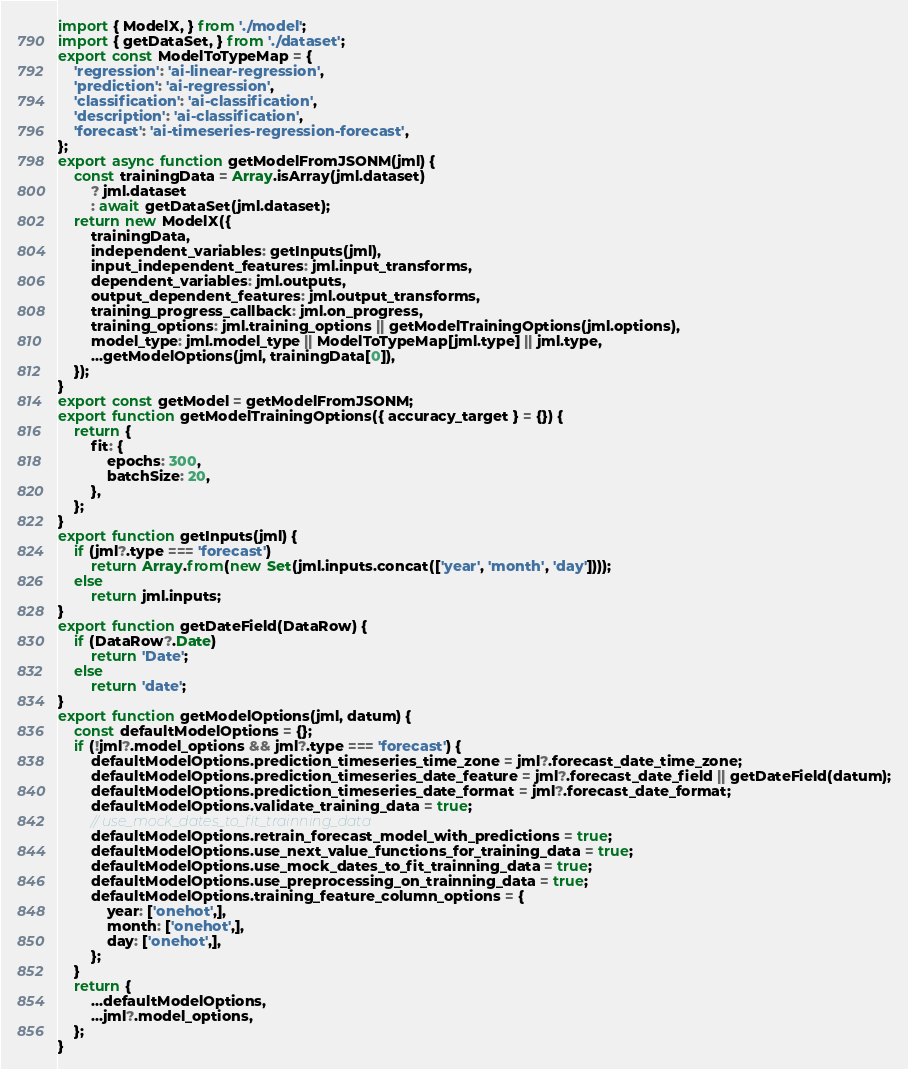Convert code to text. <code><loc_0><loc_0><loc_500><loc_500><_JavaScript_>import { ModelX, } from './model';
import { getDataSet, } from './dataset';
export const ModelToTypeMap = {
    'regression': 'ai-linear-regression',
    'prediction': 'ai-regression',
    'classification': 'ai-classification',
    'description': 'ai-classification',
    'forecast': 'ai-timeseries-regression-forecast',
};
export async function getModelFromJSONM(jml) {
    const trainingData = Array.isArray(jml.dataset)
        ? jml.dataset
        : await getDataSet(jml.dataset);
    return new ModelX({
        trainingData,
        independent_variables: getInputs(jml),
        input_independent_features: jml.input_transforms,
        dependent_variables: jml.outputs,
        output_dependent_features: jml.output_transforms,
        training_progress_callback: jml.on_progress,
        training_options: jml.training_options || getModelTrainingOptions(jml.options),
        model_type: jml.model_type || ModelToTypeMap[jml.type] || jml.type,
        ...getModelOptions(jml, trainingData[0]),
    });
}
export const getModel = getModelFromJSONM;
export function getModelTrainingOptions({ accuracy_target } = {}) {
    return {
        fit: {
            epochs: 300,
            batchSize: 20,
        },
    };
}
export function getInputs(jml) {
    if (jml?.type === 'forecast')
        return Array.from(new Set(jml.inputs.concat(['year', 'month', 'day'])));
    else
        return jml.inputs;
}
export function getDateField(DataRow) {
    if (DataRow?.Date)
        return 'Date';
    else
        return 'date';
}
export function getModelOptions(jml, datum) {
    const defaultModelOptions = {};
    if (!jml?.model_options && jml?.type === 'forecast') {
        defaultModelOptions.prediction_timeseries_time_zone = jml?.forecast_date_time_zone;
        defaultModelOptions.prediction_timeseries_date_feature = jml?.forecast_date_field || getDateField(datum);
        defaultModelOptions.prediction_timeseries_date_format = jml?.forecast_date_format;
        defaultModelOptions.validate_training_data = true;
        // use_mock_dates_to_fit_trainning_data
        defaultModelOptions.retrain_forecast_model_with_predictions = true;
        defaultModelOptions.use_next_value_functions_for_training_data = true;
        defaultModelOptions.use_mock_dates_to_fit_trainning_data = true;
        defaultModelOptions.use_preprocessing_on_trainning_data = true;
        defaultModelOptions.training_feature_column_options = {
            year: ['onehot',],
            month: ['onehot',],
            day: ['onehot',],
        };
    }
    return {
        ...defaultModelOptions,
        ...jml?.model_options,
    };
}
</code> 